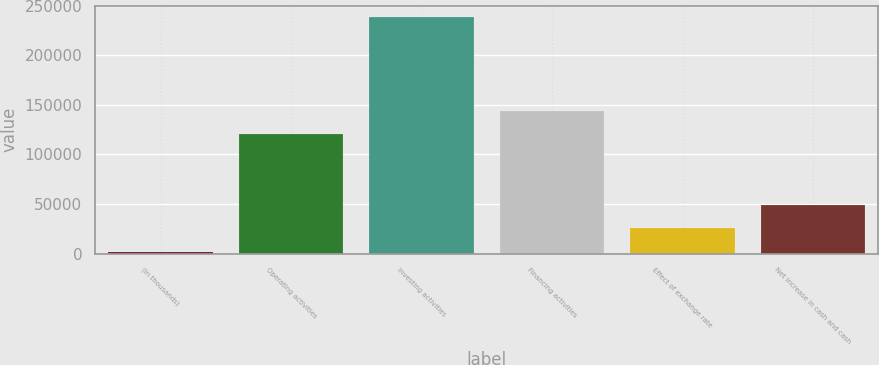<chart> <loc_0><loc_0><loc_500><loc_500><bar_chart><fcel>(In thousands)<fcel>Operating activities<fcel>Investing activities<fcel>Financing activities<fcel>Effect of exchange rate<fcel>Net increase in cash and cash<nl><fcel>2013<fcel>120070<fcel>238102<fcel>143679<fcel>25621.9<fcel>49230.8<nl></chart> 